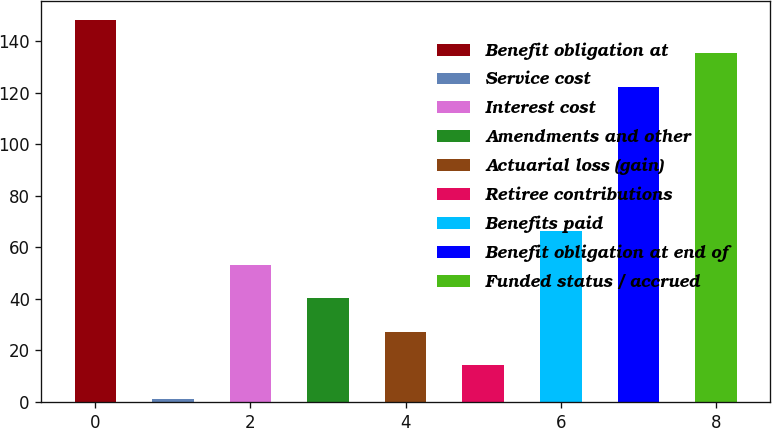Convert chart to OTSL. <chart><loc_0><loc_0><loc_500><loc_500><bar_chart><fcel>Benefit obligation at<fcel>Service cost<fcel>Interest cost<fcel>Amendments and other<fcel>Actuarial loss (gain)<fcel>Retiree contributions<fcel>Benefits paid<fcel>Benefit obligation at end of<fcel>Funded status / accrued<nl><fcel>148.38<fcel>1.3<fcel>53.26<fcel>40.27<fcel>27.28<fcel>14.29<fcel>66.25<fcel>122.4<fcel>135.39<nl></chart> 